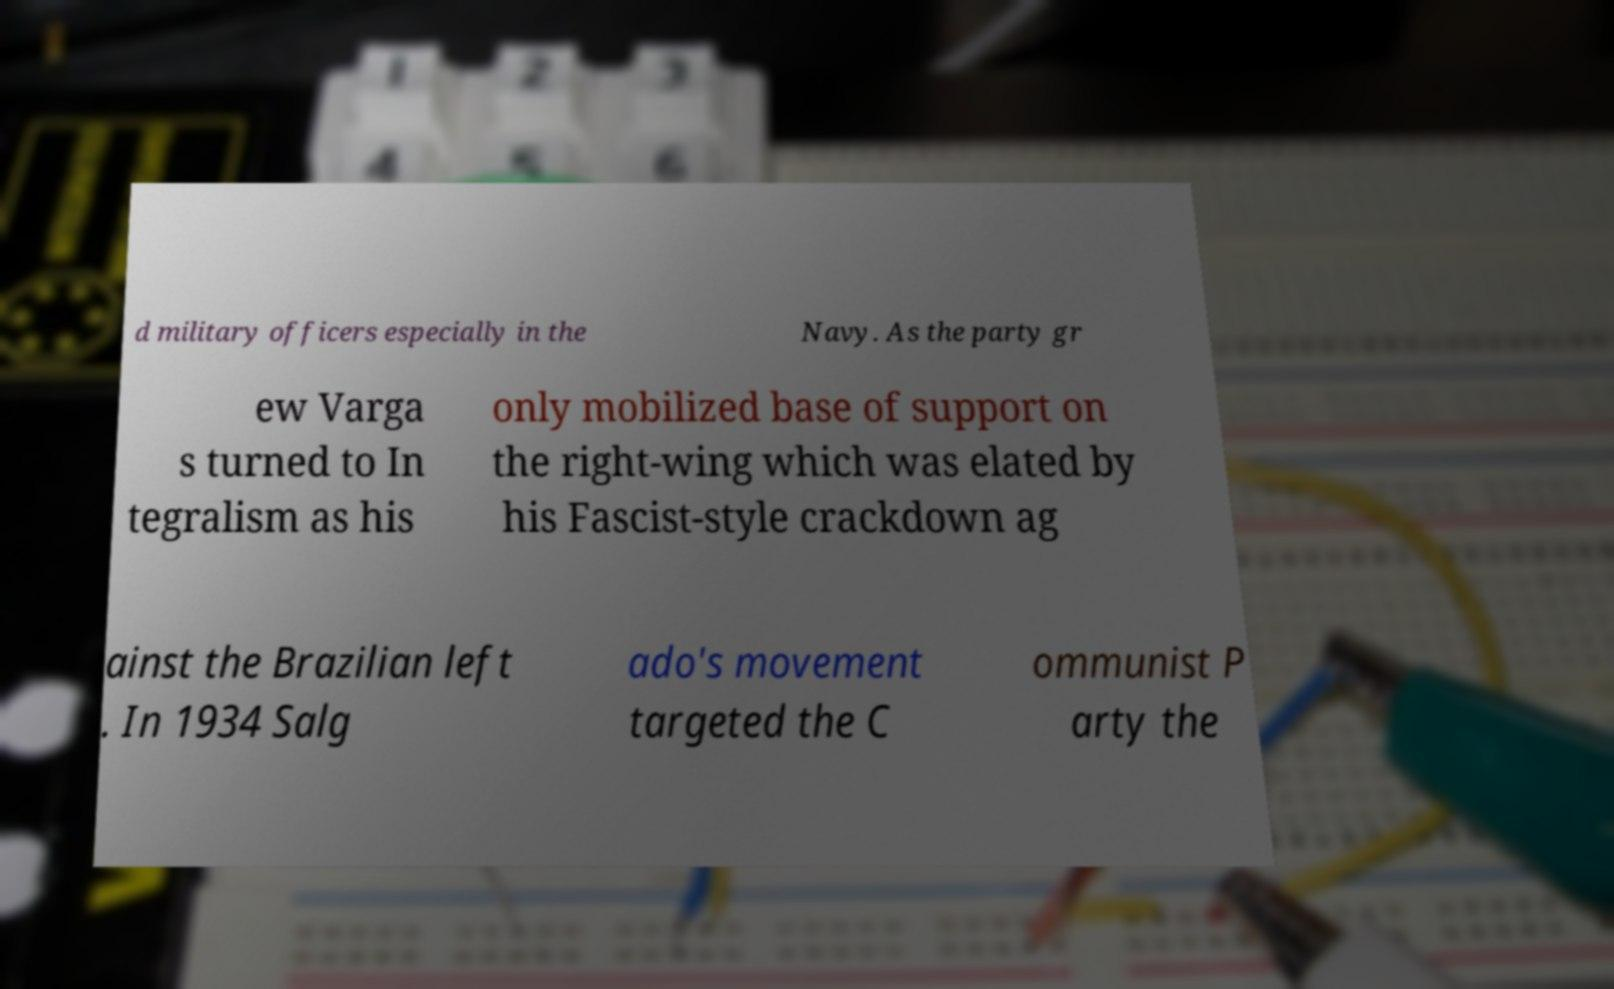Could you assist in decoding the text presented in this image and type it out clearly? d military officers especially in the Navy. As the party gr ew Varga s turned to In tegralism as his only mobilized base of support on the right-wing which was elated by his Fascist-style crackdown ag ainst the Brazilian left . In 1934 Salg ado's movement targeted the C ommunist P arty the 